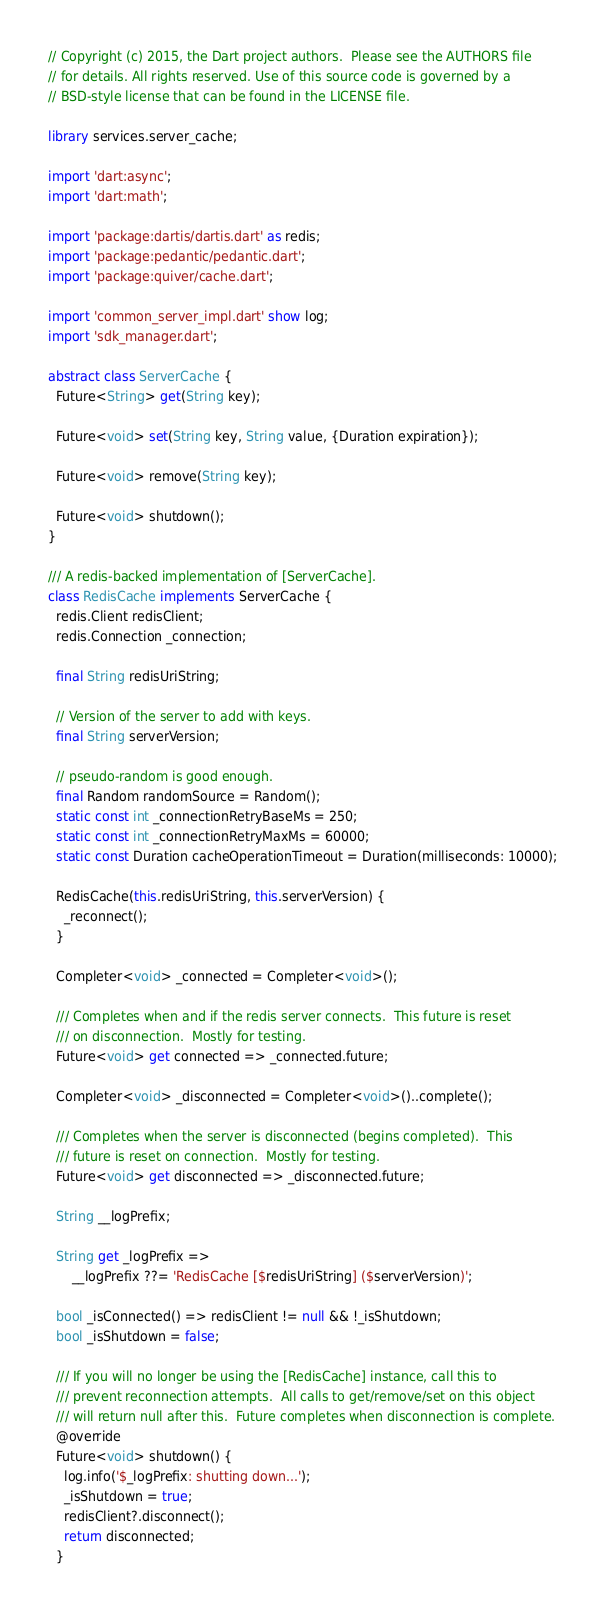Convert code to text. <code><loc_0><loc_0><loc_500><loc_500><_Dart_>// Copyright (c) 2015, the Dart project authors.  Please see the AUTHORS file
// for details. All rights reserved. Use of this source code is governed by a
// BSD-style license that can be found in the LICENSE file.

library services.server_cache;

import 'dart:async';
import 'dart:math';

import 'package:dartis/dartis.dart' as redis;
import 'package:pedantic/pedantic.dart';
import 'package:quiver/cache.dart';

import 'common_server_impl.dart' show log;
import 'sdk_manager.dart';

abstract class ServerCache {
  Future<String> get(String key);

  Future<void> set(String key, String value, {Duration expiration});

  Future<void> remove(String key);

  Future<void> shutdown();
}

/// A redis-backed implementation of [ServerCache].
class RedisCache implements ServerCache {
  redis.Client redisClient;
  redis.Connection _connection;

  final String redisUriString;

  // Version of the server to add with keys.
  final String serverVersion;

  // pseudo-random is good enough.
  final Random randomSource = Random();
  static const int _connectionRetryBaseMs = 250;
  static const int _connectionRetryMaxMs = 60000;
  static const Duration cacheOperationTimeout = Duration(milliseconds: 10000);

  RedisCache(this.redisUriString, this.serverVersion) {
    _reconnect();
  }

  Completer<void> _connected = Completer<void>();

  /// Completes when and if the redis server connects.  This future is reset
  /// on disconnection.  Mostly for testing.
  Future<void> get connected => _connected.future;

  Completer<void> _disconnected = Completer<void>()..complete();

  /// Completes when the server is disconnected (begins completed).  This
  /// future is reset on connection.  Mostly for testing.
  Future<void> get disconnected => _disconnected.future;

  String __logPrefix;

  String get _logPrefix =>
      __logPrefix ??= 'RedisCache [$redisUriString] ($serverVersion)';

  bool _isConnected() => redisClient != null && !_isShutdown;
  bool _isShutdown = false;

  /// If you will no longer be using the [RedisCache] instance, call this to
  /// prevent reconnection attempts.  All calls to get/remove/set on this object
  /// will return null after this.  Future completes when disconnection is complete.
  @override
  Future<void> shutdown() {
    log.info('$_logPrefix: shutting down...');
    _isShutdown = true;
    redisClient?.disconnect();
    return disconnected;
  }
</code> 